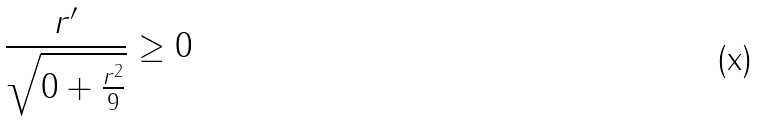<formula> <loc_0><loc_0><loc_500><loc_500>\frac { r ^ { \prime } } { \sqrt { 0 + \frac { r ^ { 2 } } { 9 } } } \geq 0</formula> 